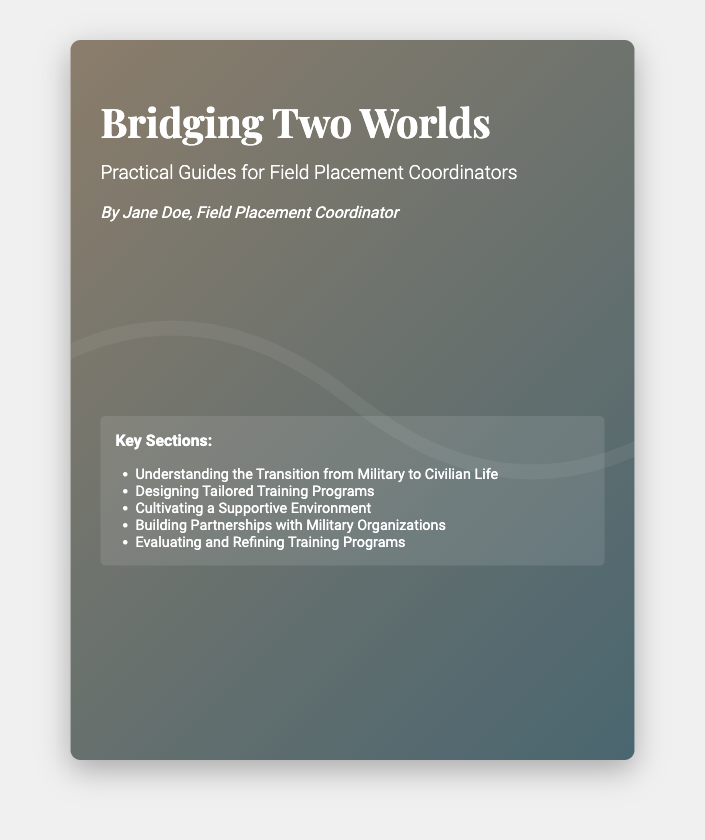What is the title of the book? The title is prominently displayed on the cover as the main heading.
Answer: Bridging Two Worlds Who is the author of the book? The author’s name is included in the author section of the cover.
Answer: Jane Doe What is the subtitle of the book? The subtitle explains the book's focus and is located under the title.
Answer: Practical Guides for Field Placement Coordinators What year is the book published? The publication year is stated in the publisher section of the cover.
Answer: 2024 Name one of the key sections listed in the document. The key sections are provided as a list, showcasing important topics covered in the book.
Answer: Understanding the Transition from Military to Civilian Life What is the color scheme of the book cover? The background colors and design elements are integral to the book's visual appeal and can be observed directly on the cover.
Answer: Gradient of brown and teal What organization is the book published by? The publisher's name is included at the bottom part of the cover.
Answer: Social Work Press How many key sections are listed in the document? The total number of key sections can be counted in the key sections list.
Answer: Five What is the main theme of the book based on the title? The title indicates a focus on transitioning from one world to another, relevant to the context of field placement coordination.
Answer: Transitioning military to civilian life 